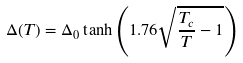<formula> <loc_0><loc_0><loc_500><loc_500>\Delta ( T ) = \Delta _ { 0 } \tanh \left ( { 1 . 7 6 \sqrt { { \frac { T _ { c } } T } - 1 } } \right )</formula> 